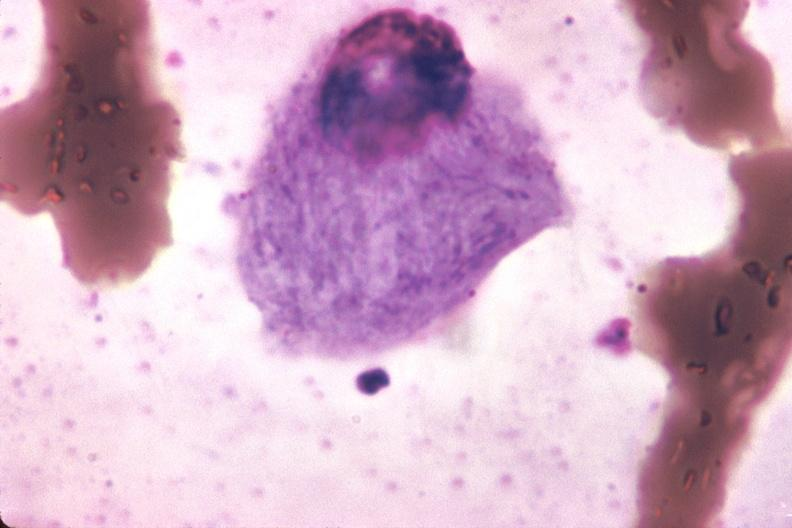what is present?
Answer the question using a single word or phrase. Hematologic 